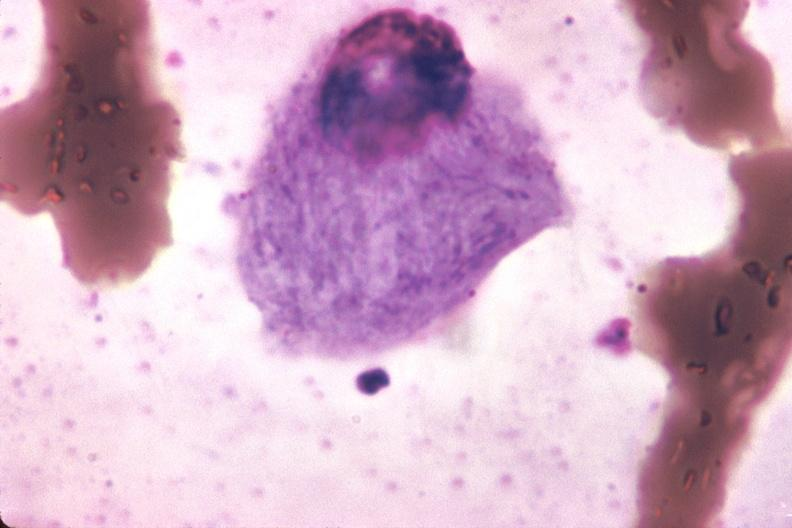what is present?
Answer the question using a single word or phrase. Hematologic 